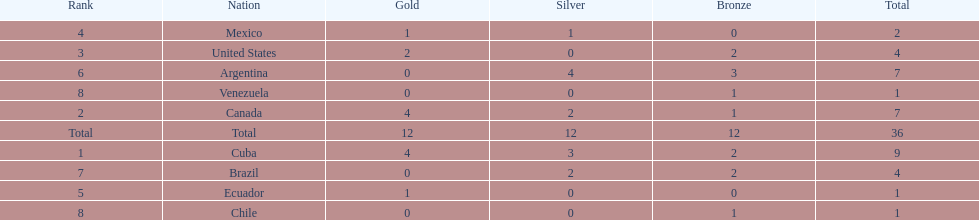What is the total number of nations that did not win gold? 4. 